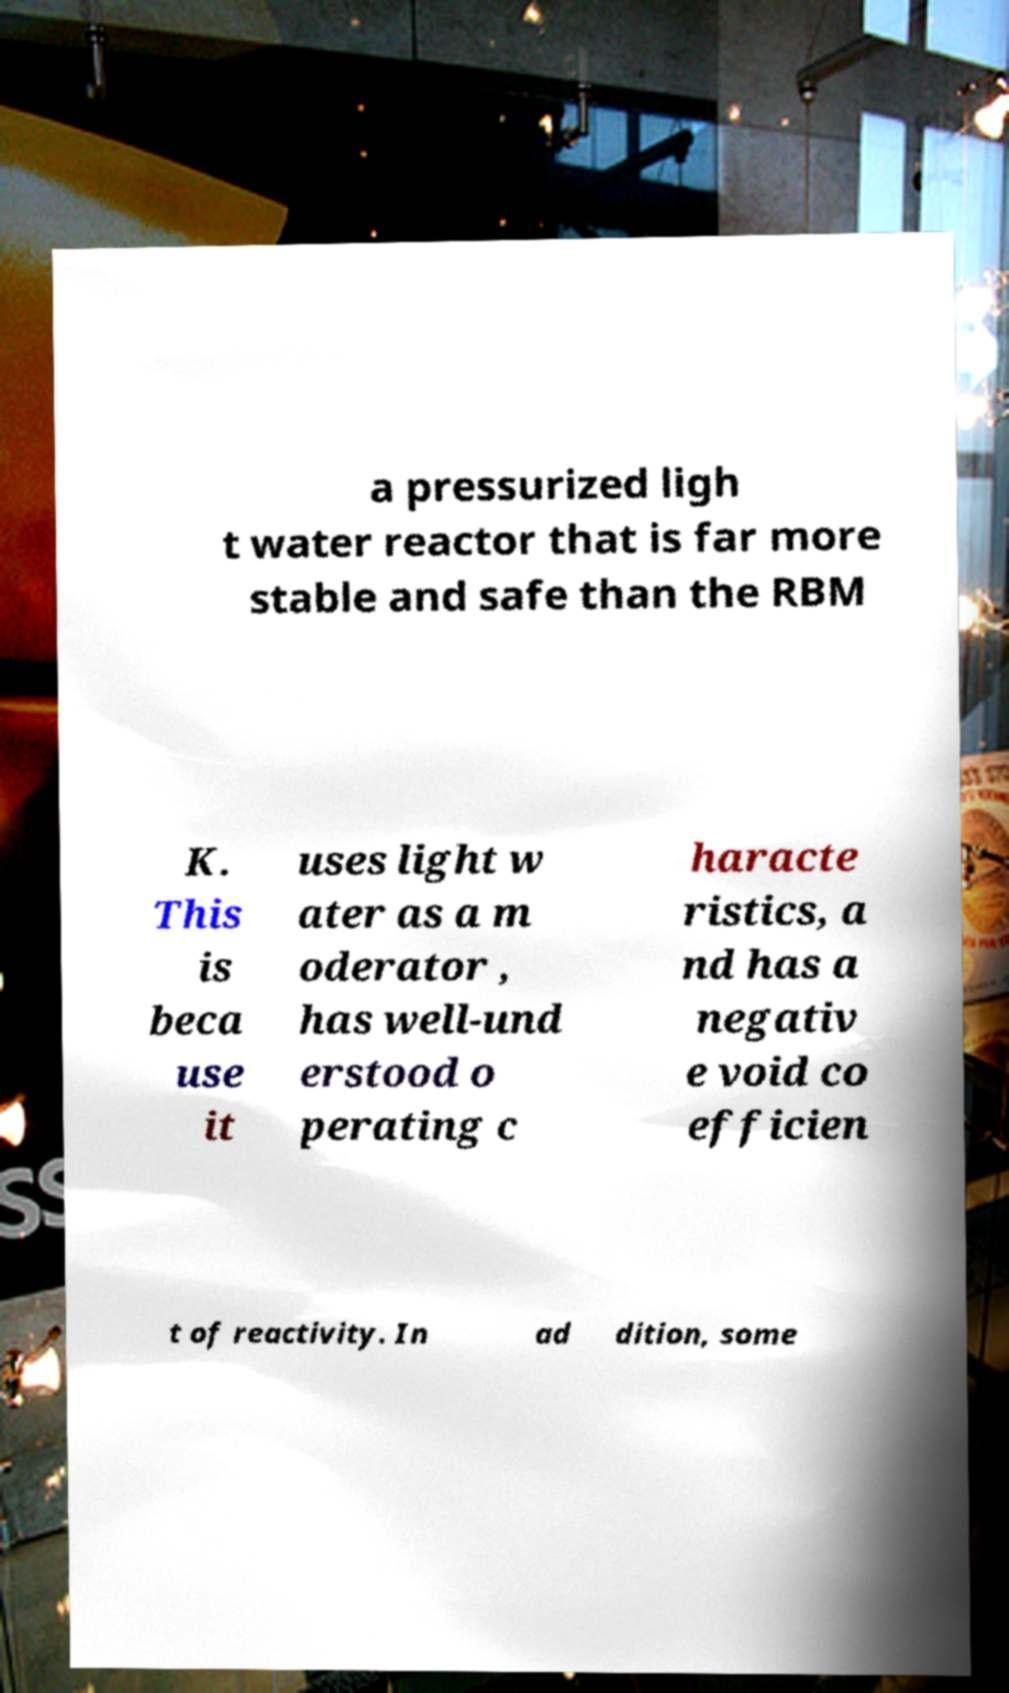Could you assist in decoding the text presented in this image and type it out clearly? a pressurized ligh t water reactor that is far more stable and safe than the RBM K. This is beca use it uses light w ater as a m oderator , has well-und erstood o perating c haracte ristics, a nd has a negativ e void co efficien t of reactivity. In ad dition, some 